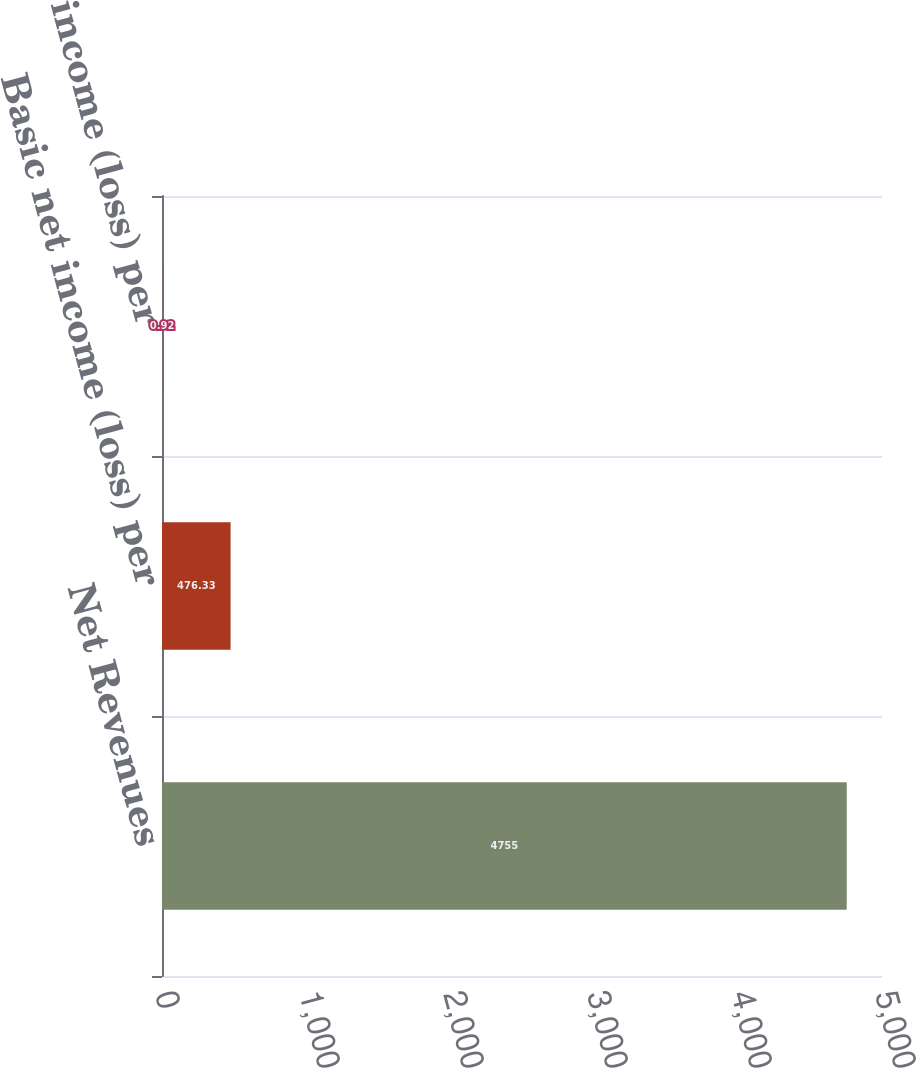Convert chart. <chart><loc_0><loc_0><loc_500><loc_500><bar_chart><fcel>Net Revenues<fcel>Basic net income (loss) per<fcel>Diluted net income (loss) per<nl><fcel>4755<fcel>476.33<fcel>0.92<nl></chart> 